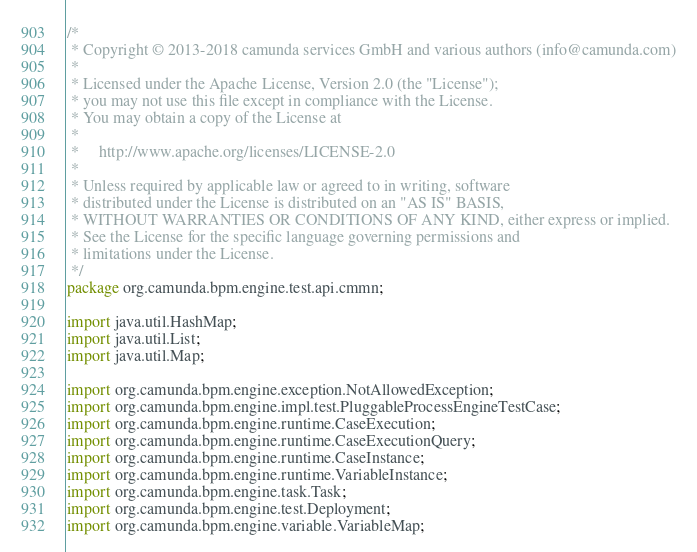Convert code to text. <code><loc_0><loc_0><loc_500><loc_500><_Java_>/*
 * Copyright © 2013-2018 camunda services GmbH and various authors (info@camunda.com)
 *
 * Licensed under the Apache License, Version 2.0 (the "License");
 * you may not use this file except in compliance with the License.
 * You may obtain a copy of the License at
 *
 *     http://www.apache.org/licenses/LICENSE-2.0
 *
 * Unless required by applicable law or agreed to in writing, software
 * distributed under the License is distributed on an "AS IS" BASIS,
 * WITHOUT WARRANTIES OR CONDITIONS OF ANY KIND, either express or implied.
 * See the License for the specific language governing permissions and
 * limitations under the License.
 */
package org.camunda.bpm.engine.test.api.cmmn;

import java.util.HashMap;
import java.util.List;
import java.util.Map;

import org.camunda.bpm.engine.exception.NotAllowedException;
import org.camunda.bpm.engine.impl.test.PluggableProcessEngineTestCase;
import org.camunda.bpm.engine.runtime.CaseExecution;
import org.camunda.bpm.engine.runtime.CaseExecutionQuery;
import org.camunda.bpm.engine.runtime.CaseInstance;
import org.camunda.bpm.engine.runtime.VariableInstance;
import org.camunda.bpm.engine.task.Task;
import org.camunda.bpm.engine.test.Deployment;
import org.camunda.bpm.engine.variable.VariableMap;</code> 